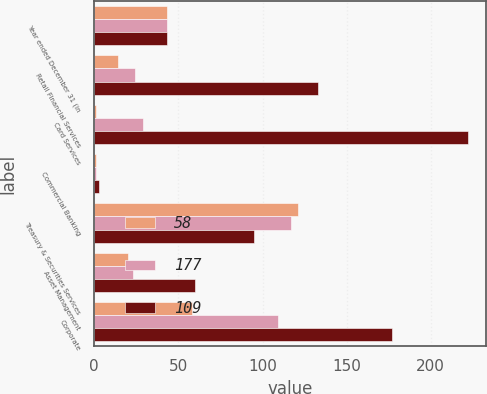<chart> <loc_0><loc_0><loc_500><loc_500><stacked_bar_chart><ecel><fcel>Year ended December 31 (in<fcel>Retail Financial Services<fcel>Card Services<fcel>Commercial Banking<fcel>Treasury & Securities Services<fcel>Asset Management<fcel>Corporate<nl><fcel>58<fcel>43.5<fcel>14<fcel>1<fcel>1<fcel>121<fcel>20<fcel>58<nl><fcel>177<fcel>43.5<fcel>24<fcel>29<fcel>1<fcel>117<fcel>23<fcel>109<nl><fcel>109<fcel>43.5<fcel>133<fcel>222<fcel>3<fcel>95<fcel>60<fcel>177<nl></chart> 